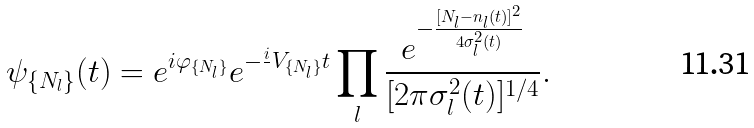<formula> <loc_0><loc_0><loc_500><loc_500>\psi _ { \{ N _ { l } \} } ( t ) = e ^ { i \varphi _ { \{ N _ { l } \} } } e ^ { - \frac { i } { } V _ { \{ N _ { l } \} } t } \prod _ { l } \frac { e ^ { - \frac { [ N _ { l } - n _ { l } ( t ) ] ^ { 2 } } { 4 \sigma _ { l } ^ { 2 } ( t ) } } } { [ 2 \pi \sigma _ { l } ^ { 2 } ( t ) ] ^ { 1 / 4 } } .</formula> 